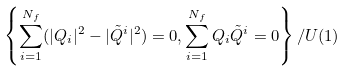Convert formula to latex. <formula><loc_0><loc_0><loc_500><loc_500>\left \{ \sum _ { i = 1 } ^ { N _ { f } } ( | Q _ { i } | ^ { 2 } - | \tilde { Q } ^ { i } | ^ { 2 } ) = 0 , \sum _ { i = 1 } ^ { N _ { f } } Q _ { i } \tilde { Q } ^ { i } = 0 \right \} / U ( 1 )</formula> 